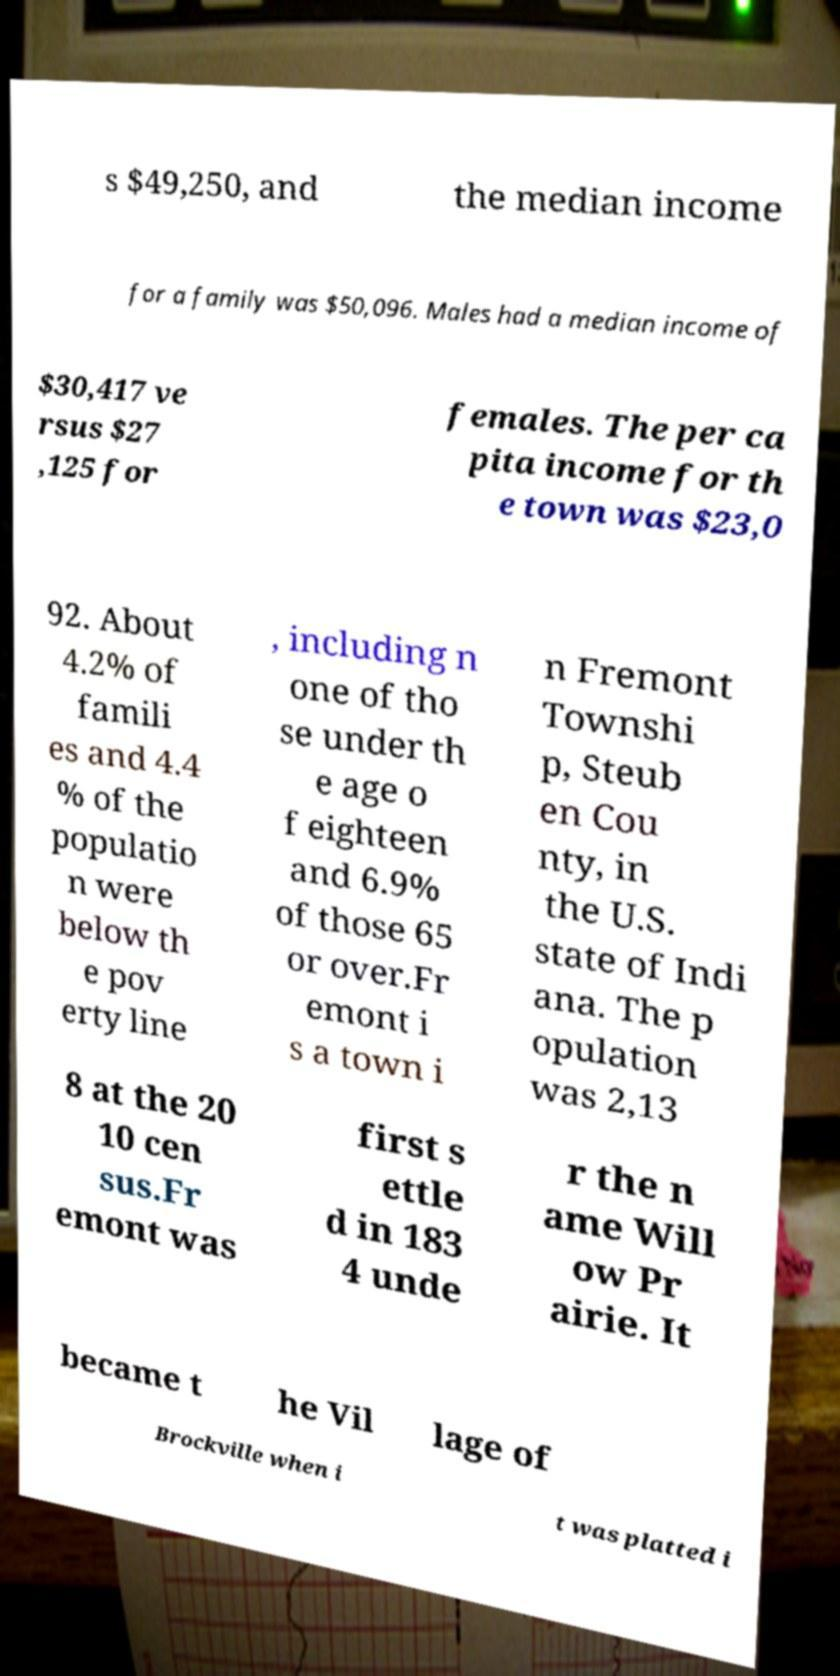Please read and relay the text visible in this image. What does it say? s $49,250, and the median income for a family was $50,096. Males had a median income of $30,417 ve rsus $27 ,125 for females. The per ca pita income for th e town was $23,0 92. About 4.2% of famili es and 4.4 % of the populatio n were below th e pov erty line , including n one of tho se under th e age o f eighteen and 6.9% of those 65 or over.Fr emont i s a town i n Fremont Townshi p, Steub en Cou nty, in the U.S. state of Indi ana. The p opulation was 2,13 8 at the 20 10 cen sus.Fr emont was first s ettle d in 183 4 unde r the n ame Will ow Pr airie. It became t he Vil lage of Brockville when i t was platted i 